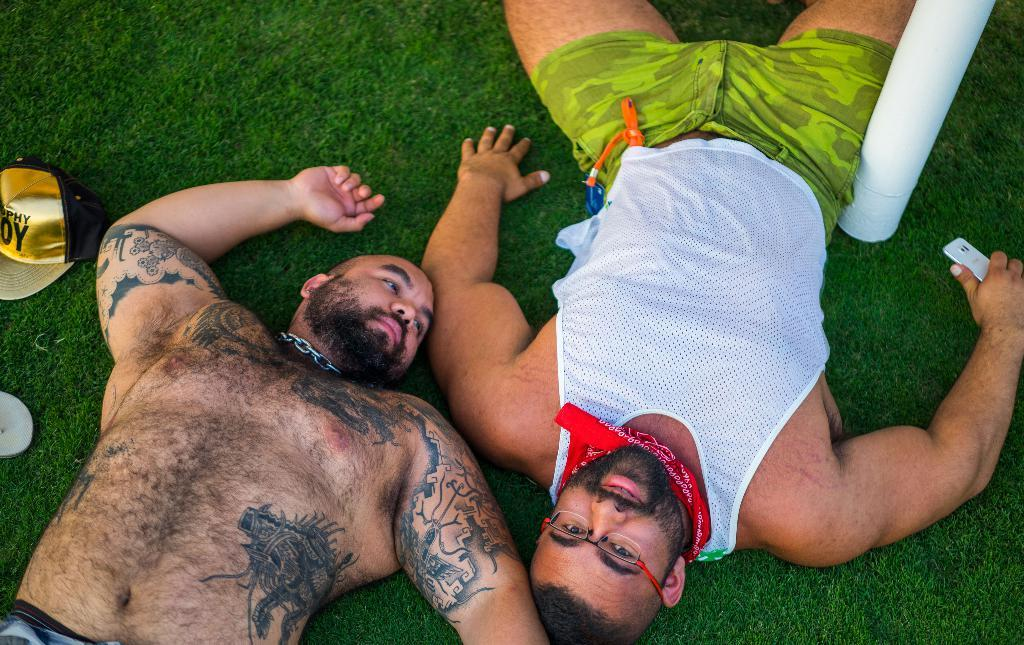How many people are in the image? There are two persons in the image. What are the persons doing in the image? The persons are lying in a garden. Can you describe any distinguishing features of the persons? One person has tattoos, and the other person is holding a mobile. What other objects can be seen in the image? There is a pole and a cap in the image. What type of disease is affecting the plants in the garden in the image? There is no indication of any disease affecting the plants in the garden in the image. Can you tell me how many buildings are visible in the image? There is no building present in the image; it features two persons lying in a garden with a pole and a cap. 